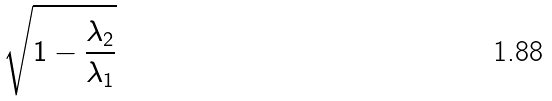<formula> <loc_0><loc_0><loc_500><loc_500>\sqrt { 1 - \frac { \lambda _ { 2 } } { \lambda _ { 1 } } }</formula> 